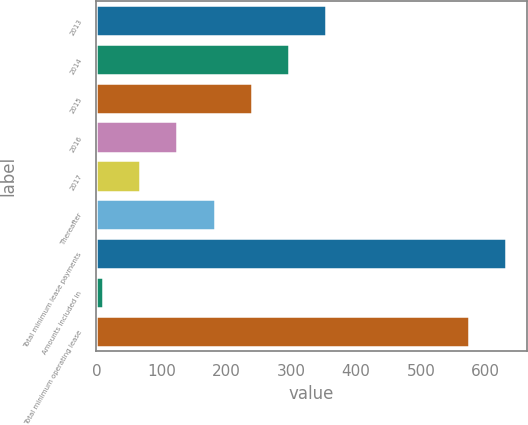Convert chart. <chart><loc_0><loc_0><loc_500><loc_500><bar_chart><fcel>2013<fcel>2014<fcel>2015<fcel>2016<fcel>2017<fcel>Thereafter<fcel>Total minimum lease payments<fcel>Amounts included in<fcel>Total minimum operating lease<nl><fcel>354.24<fcel>296.85<fcel>239.46<fcel>124.68<fcel>67.29<fcel>182.07<fcel>631.29<fcel>9.9<fcel>573.9<nl></chart> 